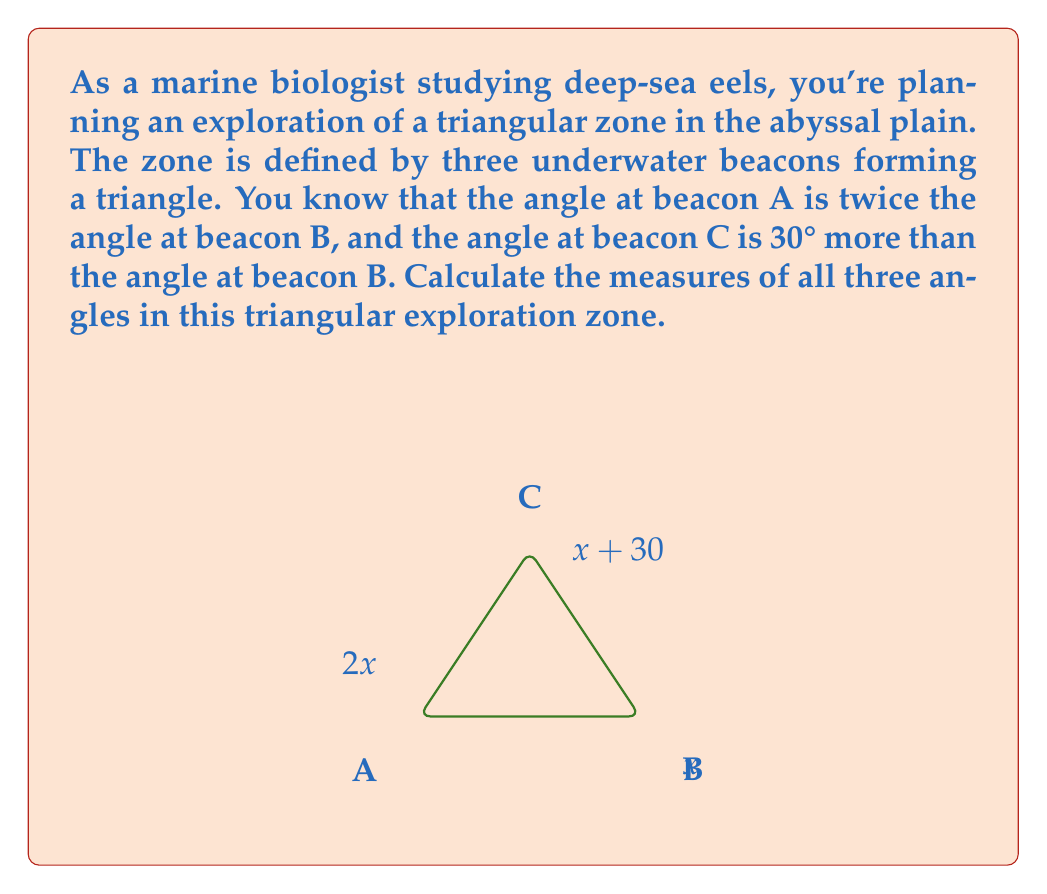Can you solve this math problem? Let's approach this step-by-step:

1) Let's denote the angle at beacon B as $x$. Given the information in the question, we can express the other angles in terms of $x$:
   - Angle at A = $2x$
   - Angle at B = $x$
   - Angle at C = $x + 30°$

2) We know that the sum of angles in a triangle is always 180°. So we can set up an equation:

   $2x + x + (x + 30°) = 180°$

3) Simplify the left side of the equation:

   $4x + 30° = 180°$

4) Subtract 30° from both sides:

   $4x = 150°$

5) Divide both sides by 4:

   $x = 37.5°$

6) Now that we know $x$, we can calculate all angles:
   - Angle at B = $x = 37.5°$
   - Angle at A = $2x = 2(37.5°) = 75°$
   - Angle at C = $x + 30° = 37.5° + 30° = 67.5°$

7) Let's verify that these angles sum to 180°:
   $75° + 37.5° + 67.5° = 180°$

Thus, our solution is consistent with the properties of a triangle.
Answer: The angles of the triangular deep-sea exploration zone are:
Angle at beacon A: $75°$
Angle at beacon B: $37.5°$
Angle at beacon C: $67.5°$ 